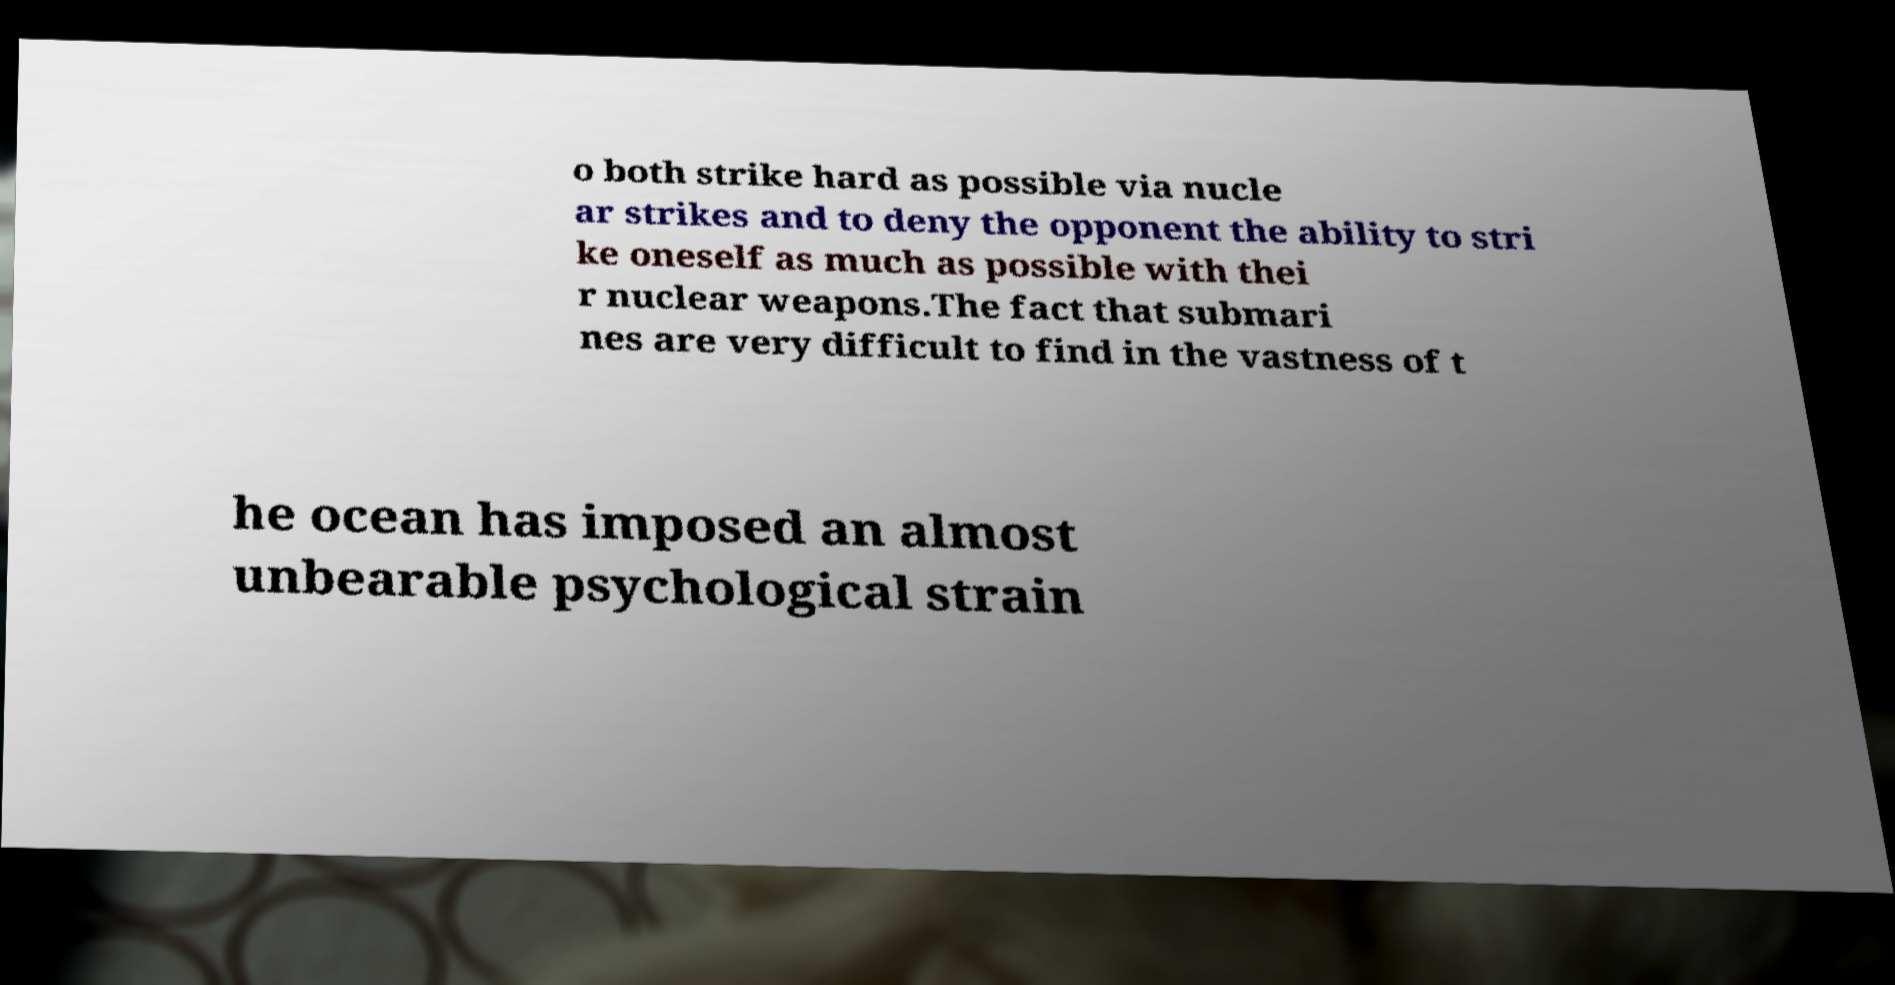What messages or text are displayed in this image? I need them in a readable, typed format. o both strike hard as possible via nucle ar strikes and to deny the opponent the ability to stri ke oneself as much as possible with thei r nuclear weapons.The fact that submari nes are very difficult to find in the vastness of t he ocean has imposed an almost unbearable psychological strain 